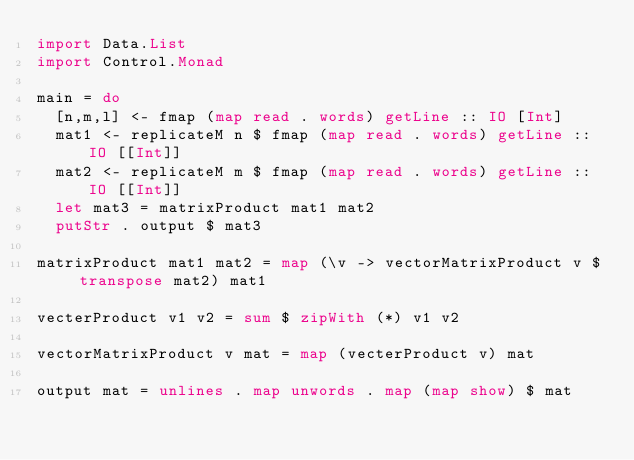<code> <loc_0><loc_0><loc_500><loc_500><_Haskell_>import Data.List
import Control.Monad

main = do
  [n,m,l] <- fmap (map read . words) getLine :: IO [Int]
  mat1 <- replicateM n $ fmap (map read . words) getLine :: IO [[Int]]
  mat2 <- replicateM m $ fmap (map read . words) getLine :: IO [[Int]]
  let mat3 = matrixProduct mat1 mat2
  putStr . output $ mat3

matrixProduct mat1 mat2 = map (\v -> vectorMatrixProduct v $ transpose mat2) mat1

vecterProduct v1 v2 = sum $ zipWith (*) v1 v2

vectorMatrixProduct v mat = map (vecterProduct v) mat

output mat = unlines . map unwords . map (map show) $ mat

</code> 